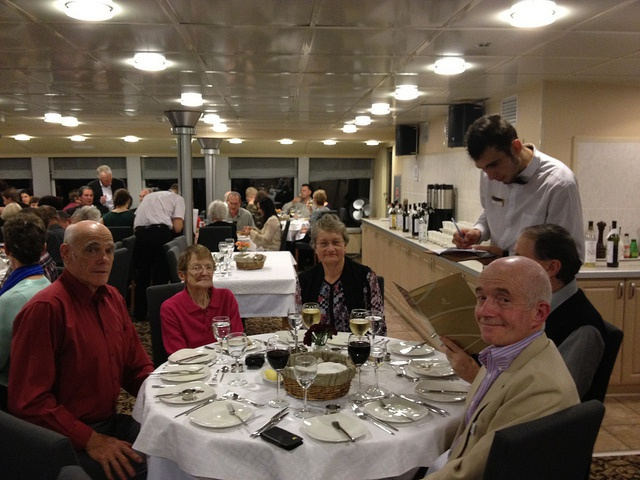Describe the objects in this image and their specific colors. I can see people in black, maroon, and gray tones, dining table in black, darkgray, gray, and lightgray tones, people in black, gray, and maroon tones, people in black, gray, maroon, and darkgray tones, and people in black, gray, and maroon tones in this image. 